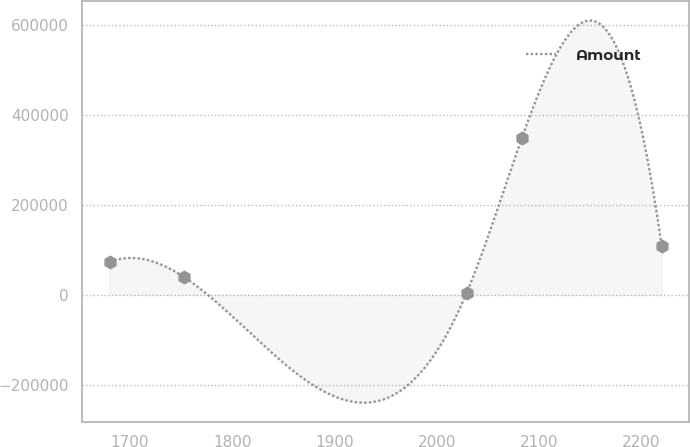Convert chart. <chart><loc_0><loc_0><loc_500><loc_500><line_chart><ecel><fcel>Amount<nl><fcel>1680.34<fcel>73424.9<nl><fcel>1753.3<fcel>39041.8<nl><fcel>2029.29<fcel>4658.7<nl><fcel>2083.24<fcel>348490<nl><fcel>2219.88<fcel>107808<nl></chart> 